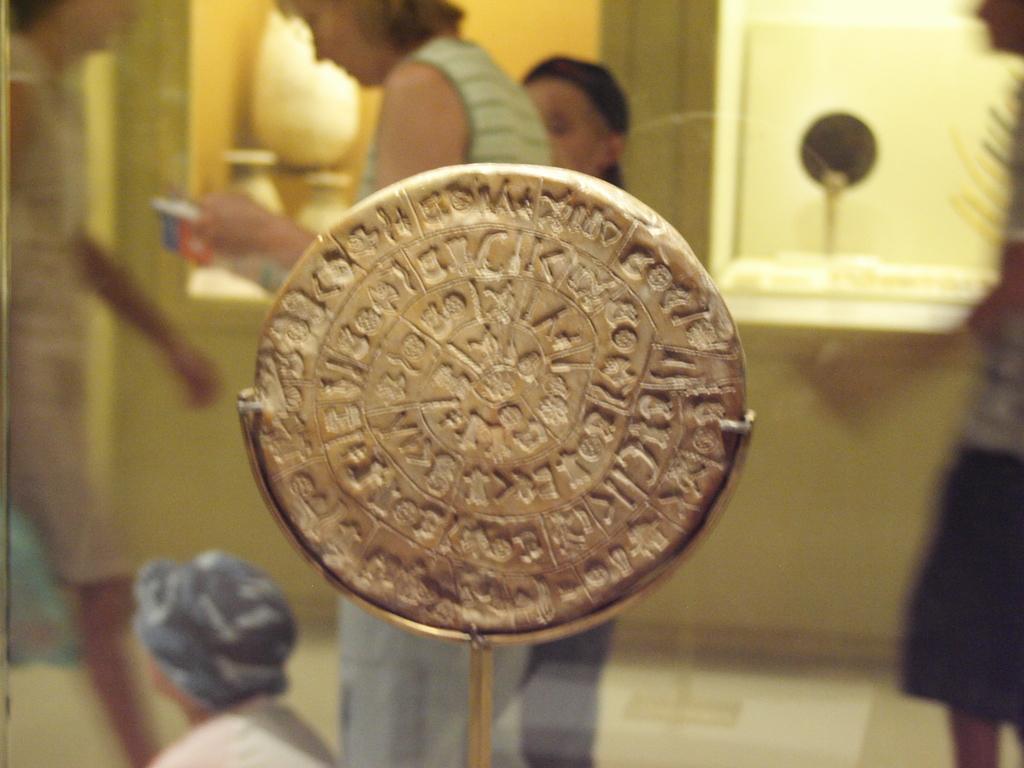Describe this image in one or two sentences. In the given image i can see a metal object,people standing and in the background i can see the window. 